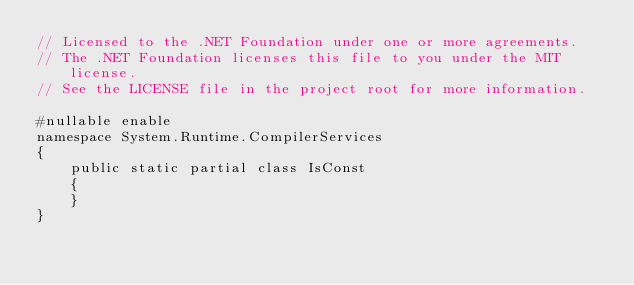<code> <loc_0><loc_0><loc_500><loc_500><_C#_>// Licensed to the .NET Foundation under one or more agreements.
// The .NET Foundation licenses this file to you under the MIT license.
// See the LICENSE file in the project root for more information.

#nullable enable
namespace System.Runtime.CompilerServices
{
    public static partial class IsConst
    {
    }
}
</code> 